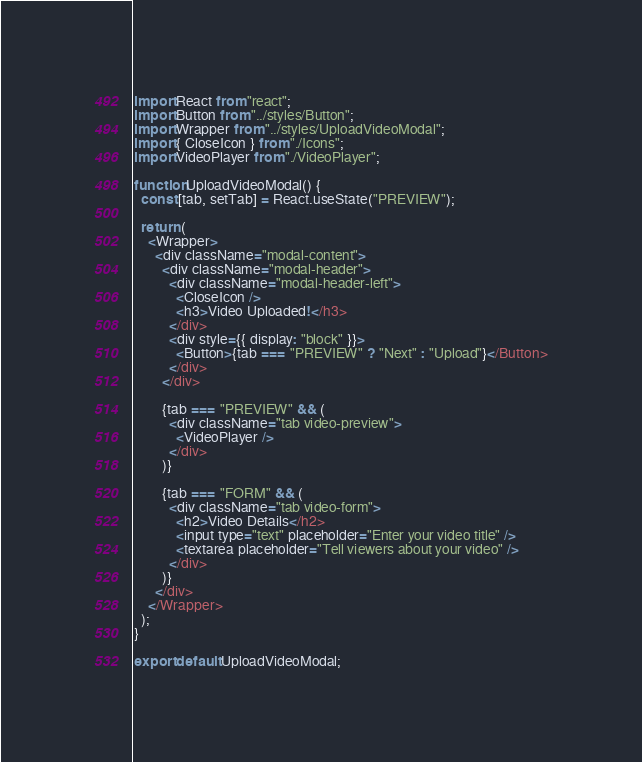<code> <loc_0><loc_0><loc_500><loc_500><_JavaScript_>import React from "react";
import Button from "../styles/Button";
import Wrapper from "../styles/UploadVideoModal";
import { CloseIcon } from "./Icons";
import VideoPlayer from "./VideoPlayer";

function UploadVideoModal() {
  const [tab, setTab] = React.useState("PREVIEW");

  return (
    <Wrapper>
      <div className="modal-content">
        <div className="modal-header">
          <div className="modal-header-left">
            <CloseIcon />
            <h3>Video Uploaded!</h3>
          </div>
          <div style={{ display: "block" }}>
            <Button>{tab === "PREVIEW" ? "Next" : "Upload"}</Button>
          </div>
        </div>

        {tab === "PREVIEW" && (
          <div className="tab video-preview">
            <VideoPlayer />
          </div>
        )}

        {tab === "FORM" && (
          <div className="tab video-form">
            <h2>Video Details</h2>
            <input type="text" placeholder="Enter your video title" />
            <textarea placeholder="Tell viewers about your video" />
          </div>
        )}
      </div>
    </Wrapper>
  );
}

export default UploadVideoModal;
</code> 